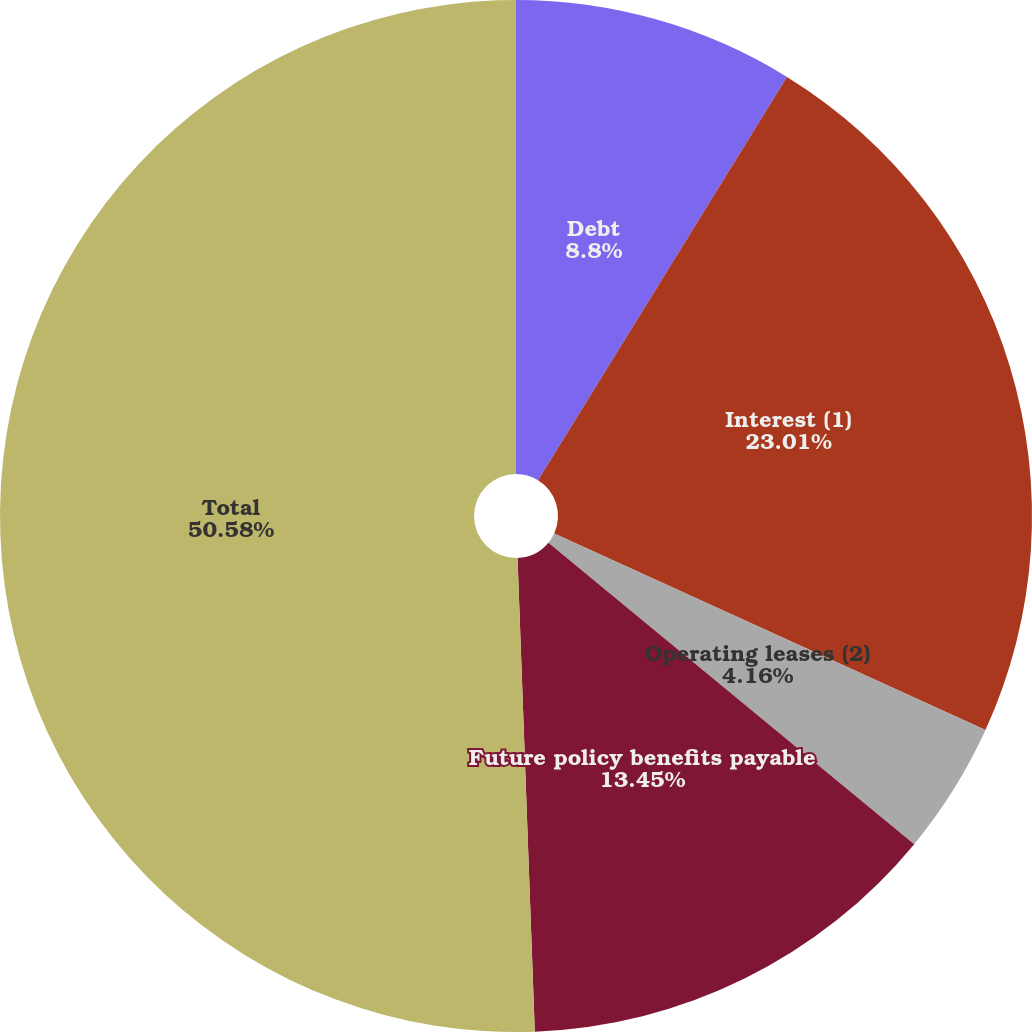<chart> <loc_0><loc_0><loc_500><loc_500><pie_chart><fcel>Debt<fcel>Interest (1)<fcel>Operating leases (2)<fcel>Future policy benefits payable<fcel>Total<nl><fcel>8.8%<fcel>23.01%<fcel>4.16%<fcel>13.45%<fcel>50.58%<nl></chart> 